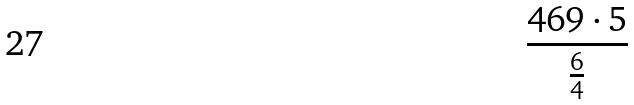Convert formula to latex. <formula><loc_0><loc_0><loc_500><loc_500>\frac { 4 6 9 \cdot 5 } { \frac { 6 } { 4 } }</formula> 